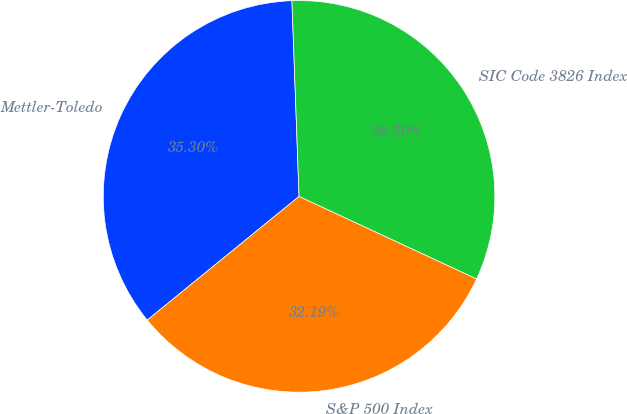<chart> <loc_0><loc_0><loc_500><loc_500><pie_chart><fcel>Mettler-Toledo<fcel>S&P 500 Index<fcel>SIC Code 3826 Index<nl><fcel>35.3%<fcel>32.19%<fcel>32.5%<nl></chart> 